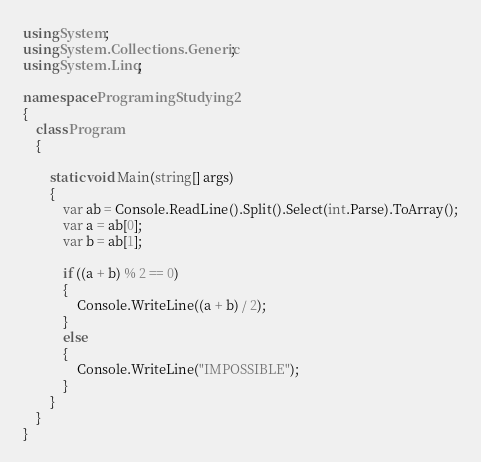<code> <loc_0><loc_0><loc_500><loc_500><_C#_>using System;
using System.Collections.Generic;
using System.Linq;

namespace ProgramingStudying2
{
    class Program
    {

        static void Main(string[] args)
        {
            var ab = Console.ReadLine().Split().Select(int.Parse).ToArray();
            var a = ab[0];
            var b = ab[1];

            if ((a + b) % 2 == 0)
            {
                Console.WriteLine((a + b) / 2);
            }
            else
            {
                Console.WriteLine("IMPOSSIBLE");
            }
        }
    }
}
</code> 